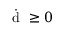Convert formula to latex. <formula><loc_0><loc_0><loc_500><loc_500>\dot { d } \geq 0</formula> 